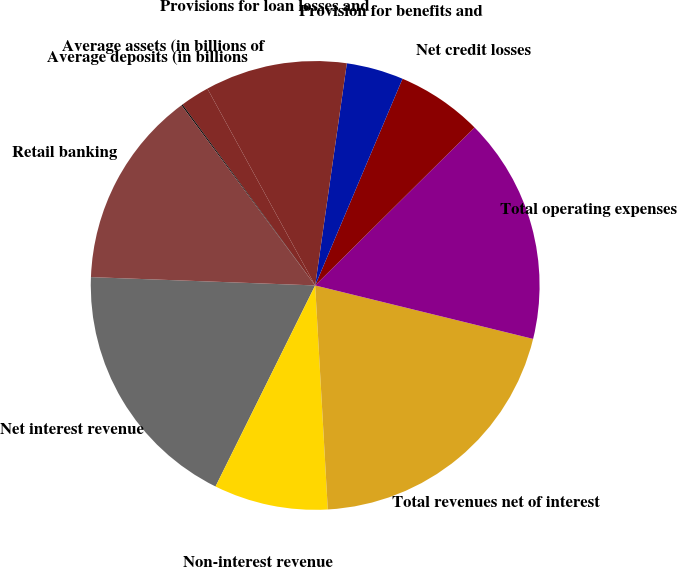Convert chart. <chart><loc_0><loc_0><loc_500><loc_500><pie_chart><fcel>Net interest revenue<fcel>Non-interest revenue<fcel>Total revenues net of interest<fcel>Total operating expenses<fcel>Net credit losses<fcel>Provision for benefits and<fcel>Provisions for loan losses and<fcel>Average assets (in billions of<fcel>Average deposits (in billions<fcel>Retail banking<nl><fcel>18.27%<fcel>8.22%<fcel>20.28%<fcel>16.26%<fcel>6.21%<fcel>4.11%<fcel>10.23%<fcel>2.1%<fcel>0.09%<fcel>14.25%<nl></chart> 